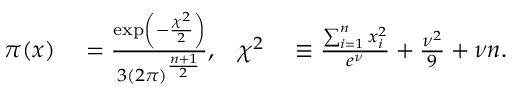<formula> <loc_0><loc_0><loc_500><loc_500>\begin{array} { r l r l } { \pi ( x ) } & = \frac { \exp \left ( - \frac { \chi ^ { 2 } } { 2 } \right ) } { 3 ( 2 \pi ) ^ { \frac { n + 1 } { 2 } } } , } & { \chi ^ { 2 } } & \equiv \frac { \sum _ { i = 1 } ^ { n } x _ { i } ^ { 2 } } { e ^ { \nu } } + \frac { \nu ^ { 2 } } { 9 } + \nu n . } \end{array}</formula> 